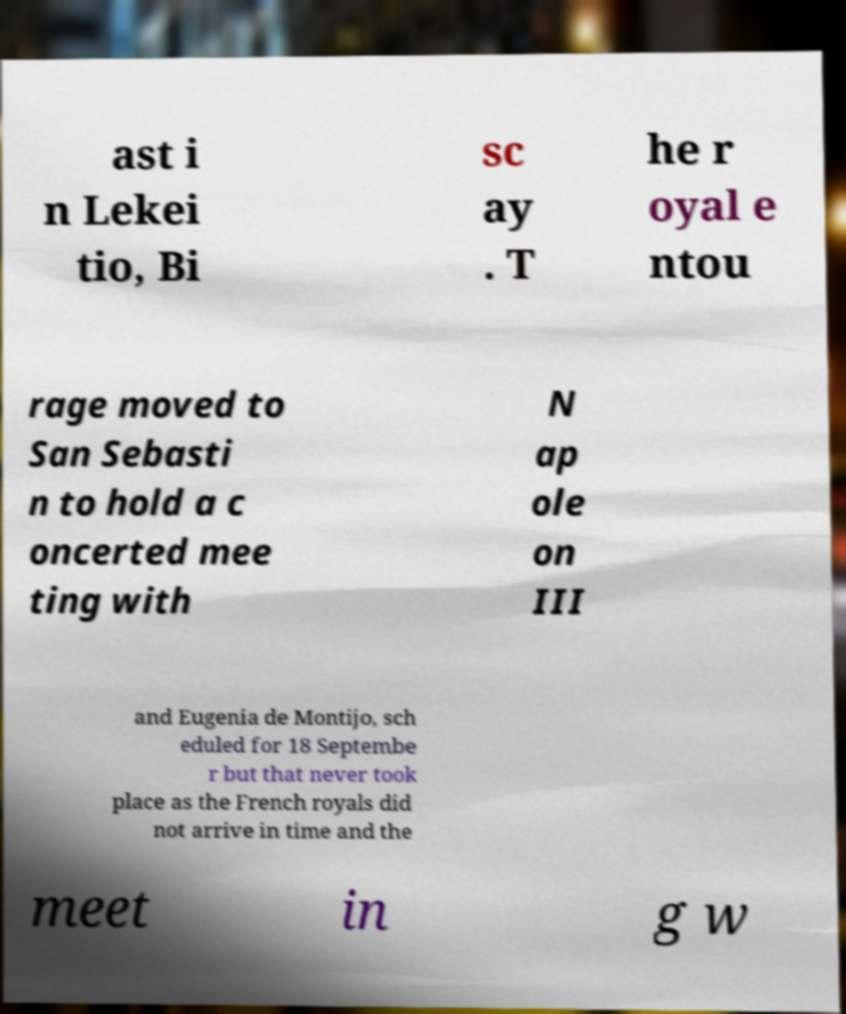Could you extract and type out the text from this image? ast i n Lekei tio, Bi sc ay . T he r oyal e ntou rage moved to San Sebasti n to hold a c oncerted mee ting with N ap ole on III and Eugenia de Montijo, sch eduled for 18 Septembe r but that never took place as the French royals did not arrive in time and the meet in g w 